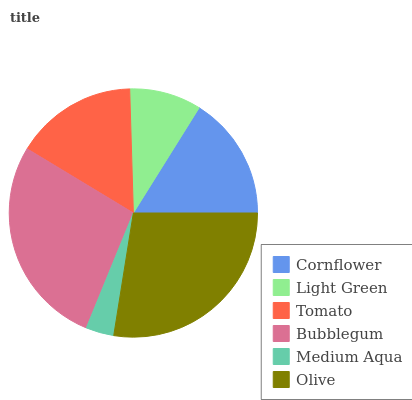Is Medium Aqua the minimum?
Answer yes or no. Yes. Is Olive the maximum?
Answer yes or no. Yes. Is Light Green the minimum?
Answer yes or no. No. Is Light Green the maximum?
Answer yes or no. No. Is Cornflower greater than Light Green?
Answer yes or no. Yes. Is Light Green less than Cornflower?
Answer yes or no. Yes. Is Light Green greater than Cornflower?
Answer yes or no. No. Is Cornflower less than Light Green?
Answer yes or no. No. Is Cornflower the high median?
Answer yes or no. Yes. Is Tomato the low median?
Answer yes or no. Yes. Is Tomato the high median?
Answer yes or no. No. Is Olive the low median?
Answer yes or no. No. 